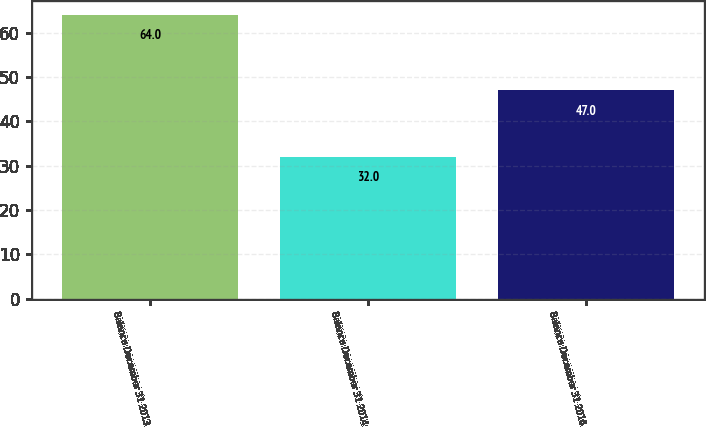<chart> <loc_0><loc_0><loc_500><loc_500><bar_chart><fcel>Balance December 31 2013<fcel>Balance December 31 2014<fcel>Balance December 31 2016<nl><fcel>64<fcel>32<fcel>47<nl></chart> 